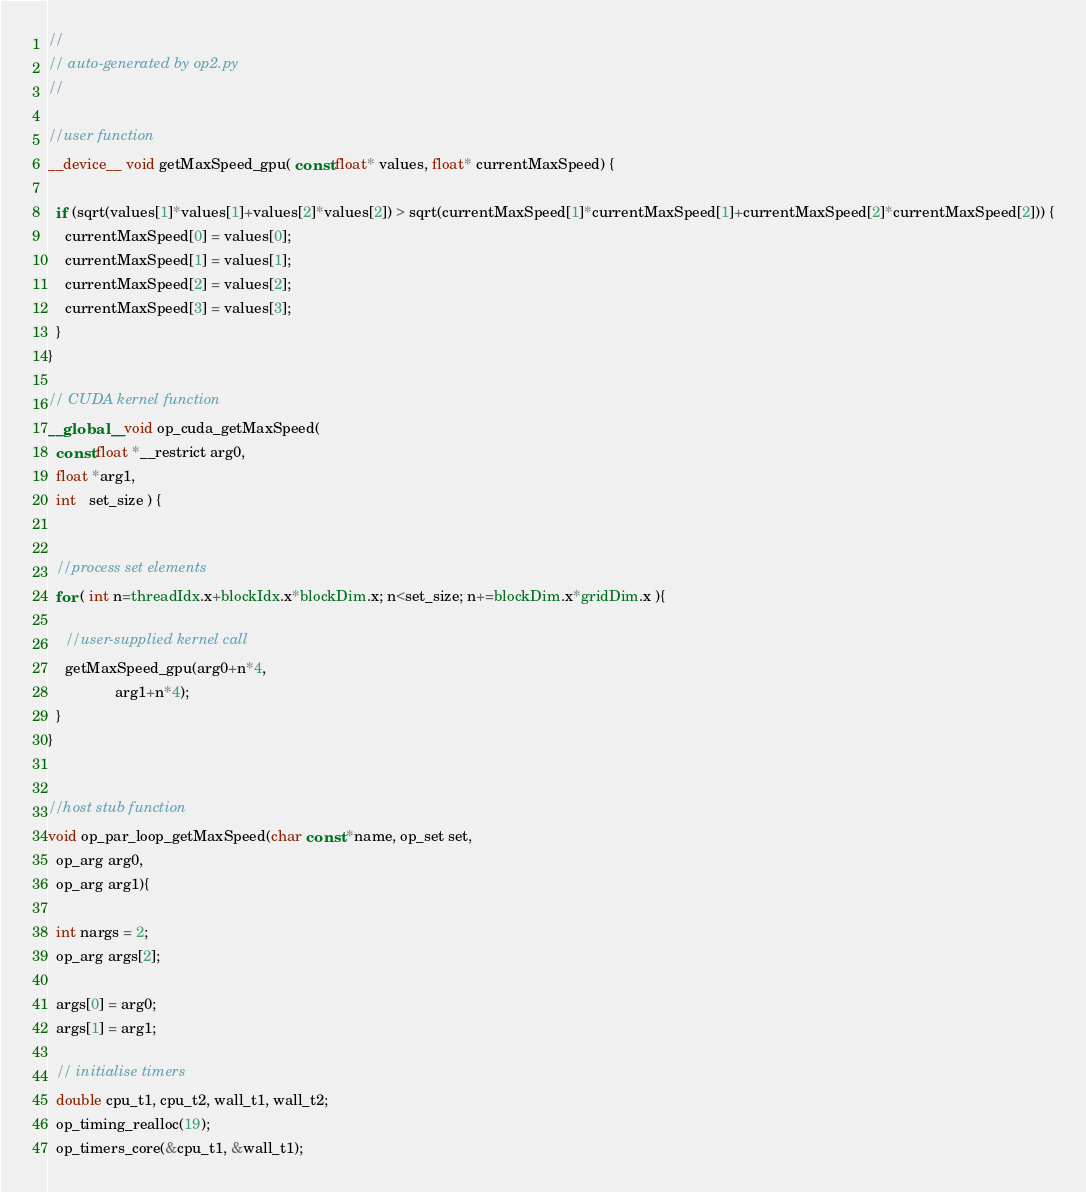Convert code to text. <code><loc_0><loc_0><loc_500><loc_500><_Cuda_>//
// auto-generated by op2.py
//

//user function
__device__ void getMaxSpeed_gpu( const float* values, float* currentMaxSpeed) {

  if (sqrt(values[1]*values[1]+values[2]*values[2]) > sqrt(currentMaxSpeed[1]*currentMaxSpeed[1]+currentMaxSpeed[2]*currentMaxSpeed[2])) {
    currentMaxSpeed[0] = values[0];
    currentMaxSpeed[1] = values[1];
    currentMaxSpeed[2] = values[2];
    currentMaxSpeed[3] = values[3];
  }
}

// CUDA kernel function
__global__ void op_cuda_getMaxSpeed(
  const float *__restrict arg0,
  float *arg1,
  int   set_size ) {


  //process set elements
  for ( int n=threadIdx.x+blockIdx.x*blockDim.x; n<set_size; n+=blockDim.x*gridDim.x ){

    //user-supplied kernel call
    getMaxSpeed_gpu(arg0+n*4,
                arg1+n*4);
  }
}


//host stub function
void op_par_loop_getMaxSpeed(char const *name, op_set set,
  op_arg arg0,
  op_arg arg1){

  int nargs = 2;
  op_arg args[2];

  args[0] = arg0;
  args[1] = arg1;

  // initialise timers
  double cpu_t1, cpu_t2, wall_t1, wall_t2;
  op_timing_realloc(19);
  op_timers_core(&cpu_t1, &wall_t1);</code> 